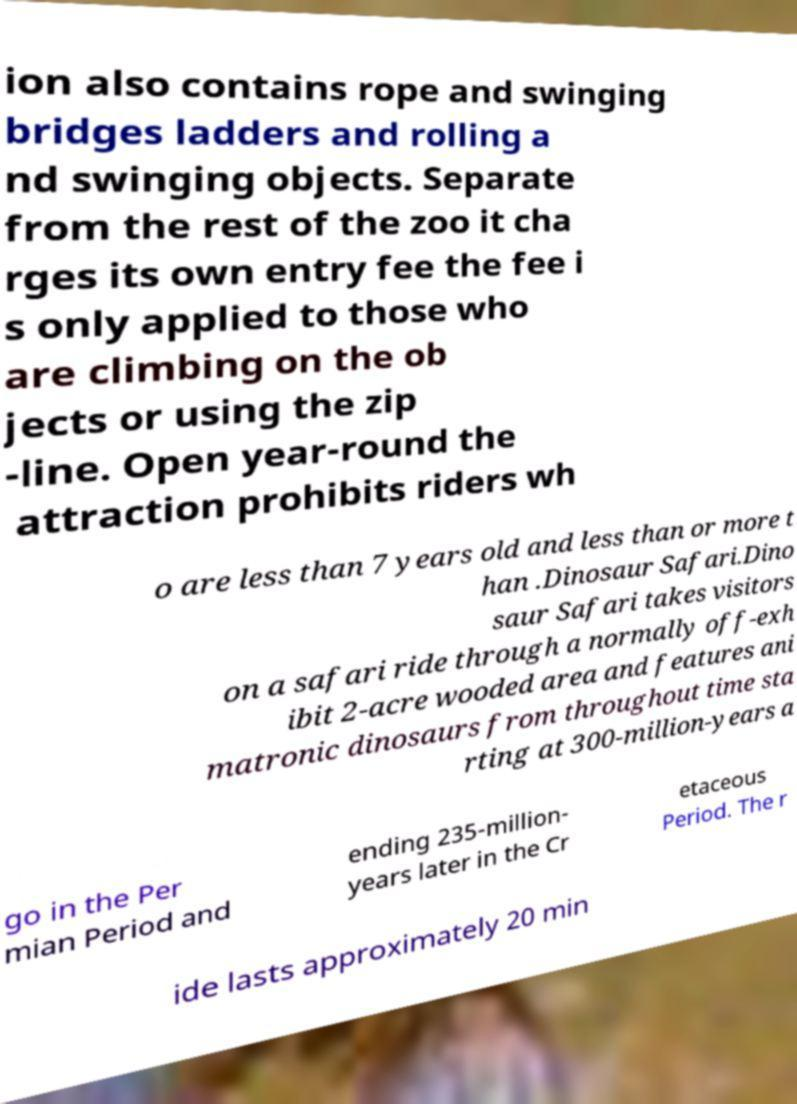There's text embedded in this image that I need extracted. Can you transcribe it verbatim? ion also contains rope and swinging bridges ladders and rolling a nd swinging objects. Separate from the rest of the zoo it cha rges its own entry fee the fee i s only applied to those who are climbing on the ob jects or using the zip -line. Open year-round the attraction prohibits riders wh o are less than 7 years old and less than or more t han .Dinosaur Safari.Dino saur Safari takes visitors on a safari ride through a normally off-exh ibit 2-acre wooded area and features ani matronic dinosaurs from throughout time sta rting at 300-million-years a go in the Per mian Period and ending 235-million- years later in the Cr etaceous Period. The r ide lasts approximately 20 min 